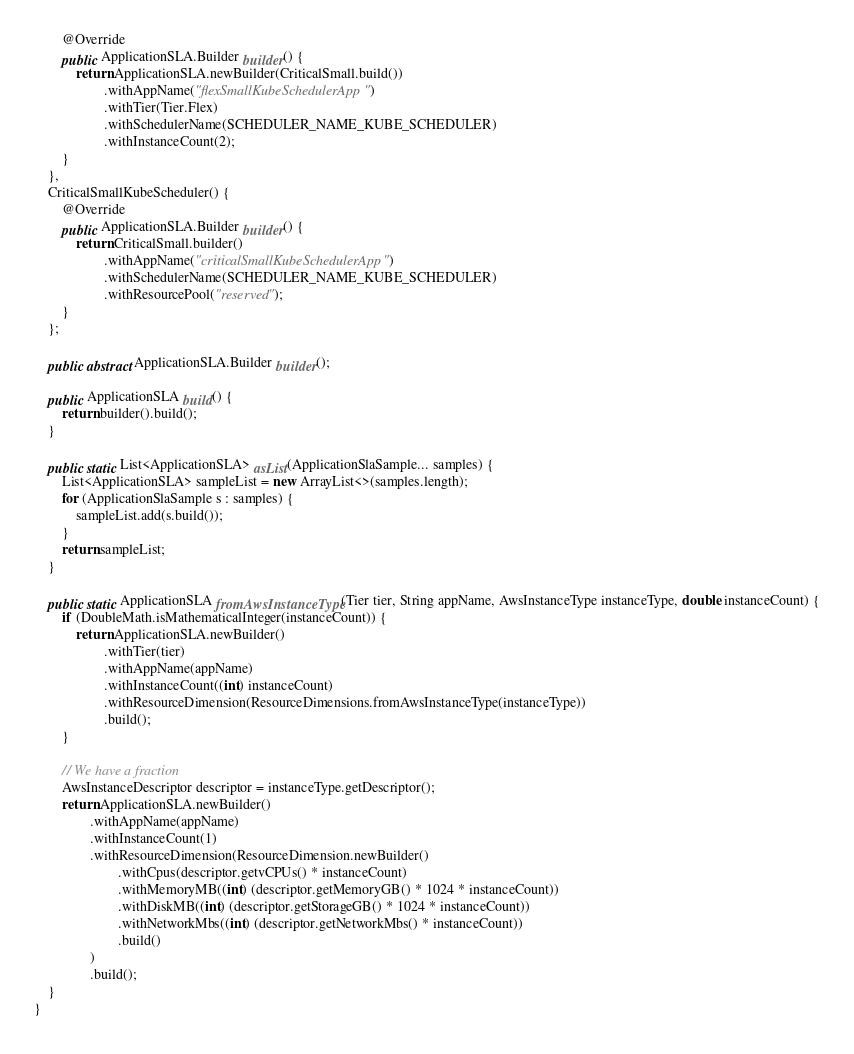<code> <loc_0><loc_0><loc_500><loc_500><_Java_>        @Override
        public ApplicationSLA.Builder builder() {
            return ApplicationSLA.newBuilder(CriticalSmall.build())
                    .withAppName("flexSmallKubeSchedulerApp")
                    .withTier(Tier.Flex)
                    .withSchedulerName(SCHEDULER_NAME_KUBE_SCHEDULER)
                    .withInstanceCount(2);
        }
    },
    CriticalSmallKubeScheduler() {
        @Override
        public ApplicationSLA.Builder builder() {
            return CriticalSmall.builder()
                    .withAppName("criticalSmallKubeSchedulerApp")
                    .withSchedulerName(SCHEDULER_NAME_KUBE_SCHEDULER)
                    .withResourcePool("reserved");
        }
    };

    public abstract ApplicationSLA.Builder builder();

    public ApplicationSLA build() {
        return builder().build();
    }

    public static List<ApplicationSLA> asList(ApplicationSlaSample... samples) {
        List<ApplicationSLA> sampleList = new ArrayList<>(samples.length);
        for (ApplicationSlaSample s : samples) {
            sampleList.add(s.build());
        }
        return sampleList;
    }

    public static ApplicationSLA fromAwsInstanceType(Tier tier, String appName, AwsInstanceType instanceType, double instanceCount) {
        if (DoubleMath.isMathematicalInteger(instanceCount)) {
            return ApplicationSLA.newBuilder()
                    .withTier(tier)
                    .withAppName(appName)
                    .withInstanceCount((int) instanceCount)
                    .withResourceDimension(ResourceDimensions.fromAwsInstanceType(instanceType))
                    .build();
        }

        // We have a fraction
        AwsInstanceDescriptor descriptor = instanceType.getDescriptor();
        return ApplicationSLA.newBuilder()
                .withAppName(appName)
                .withInstanceCount(1)
                .withResourceDimension(ResourceDimension.newBuilder()
                        .withCpus(descriptor.getvCPUs() * instanceCount)
                        .withMemoryMB((int) (descriptor.getMemoryGB() * 1024 * instanceCount))
                        .withDiskMB((int) (descriptor.getStorageGB() * 1024 * instanceCount))
                        .withNetworkMbs((int) (descriptor.getNetworkMbs() * instanceCount))
                        .build()
                )
                .build();
    }
}
</code> 